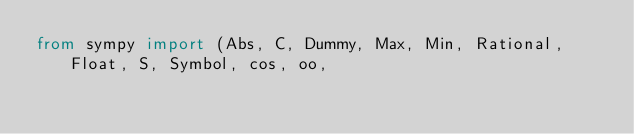Convert code to text. <code><loc_0><loc_0><loc_500><loc_500><_Python_>from sympy import (Abs, C, Dummy, Max, Min, Rational, Float, S, Symbol, cos, oo,</code> 